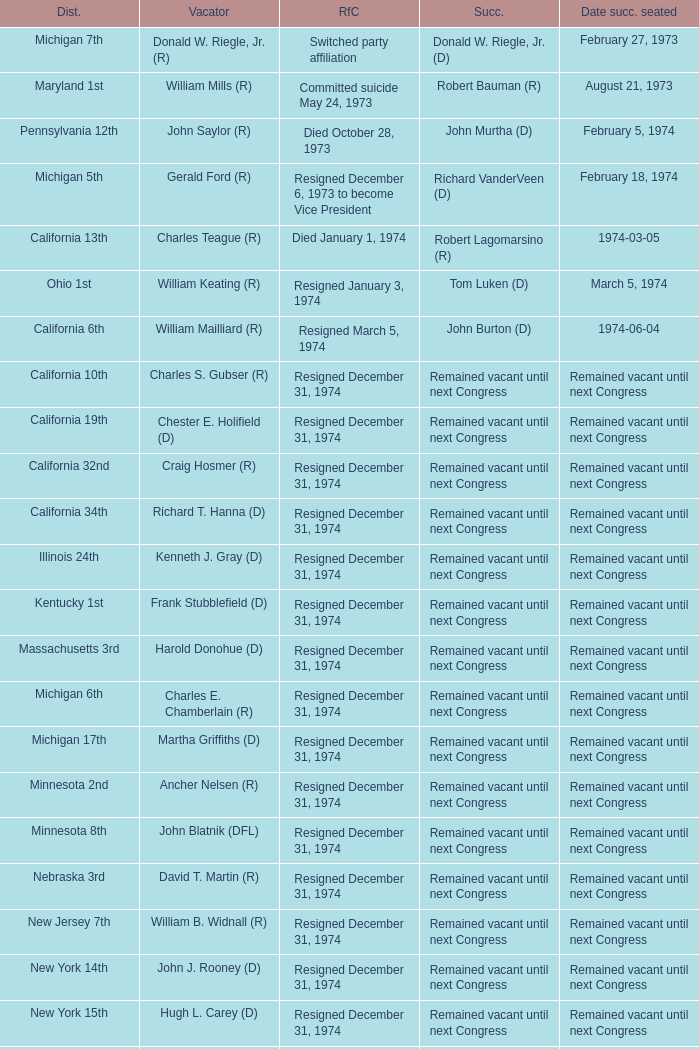Who was the vacator when the date successor seated was august 21, 1973? William Mills (R). 